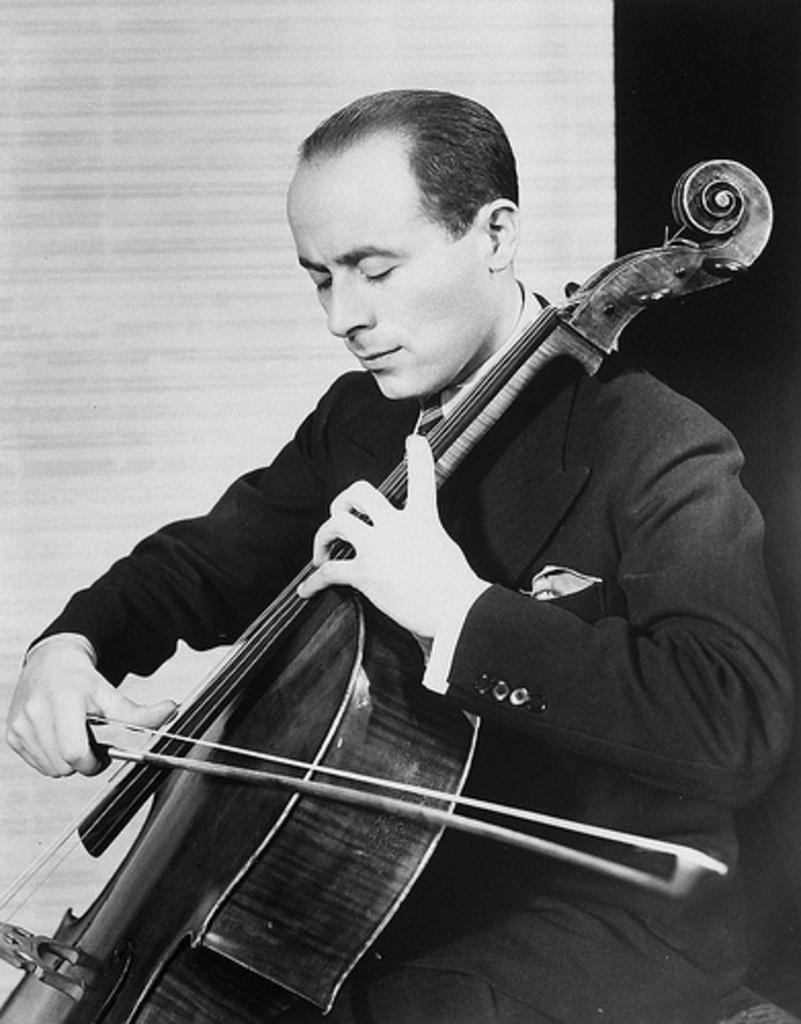What is the color scheme of the image? The image is black and white. Who is present in the image? There is a man in the image. What is the man doing in the image? The man is sitting on a chair and playing a violin. What instrument is the man playing in the image? The man is playing a violin. What type of lace is the man wearing in the image? There is no lace visible in the image, as the image is black and white and the man is not wearing any clothing that would include lace. 